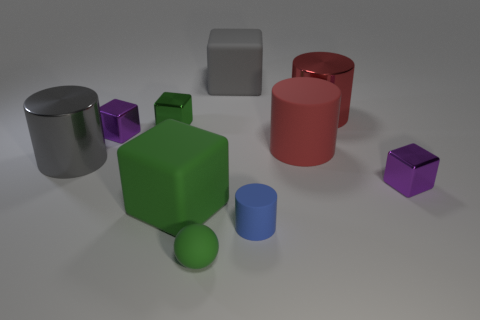Can you describe the arrangement of different objects in the image? The image showcases a collection of three-dimensional shapes scattered across a flat surface. In the foreground, there's a large green cube and a small blue cylinder. Towards the middle, a large red cylinder and a small purple cube are visible. In the background, a large silver cylinder and a small gray cube are present, all under soft, diffused lighting. 